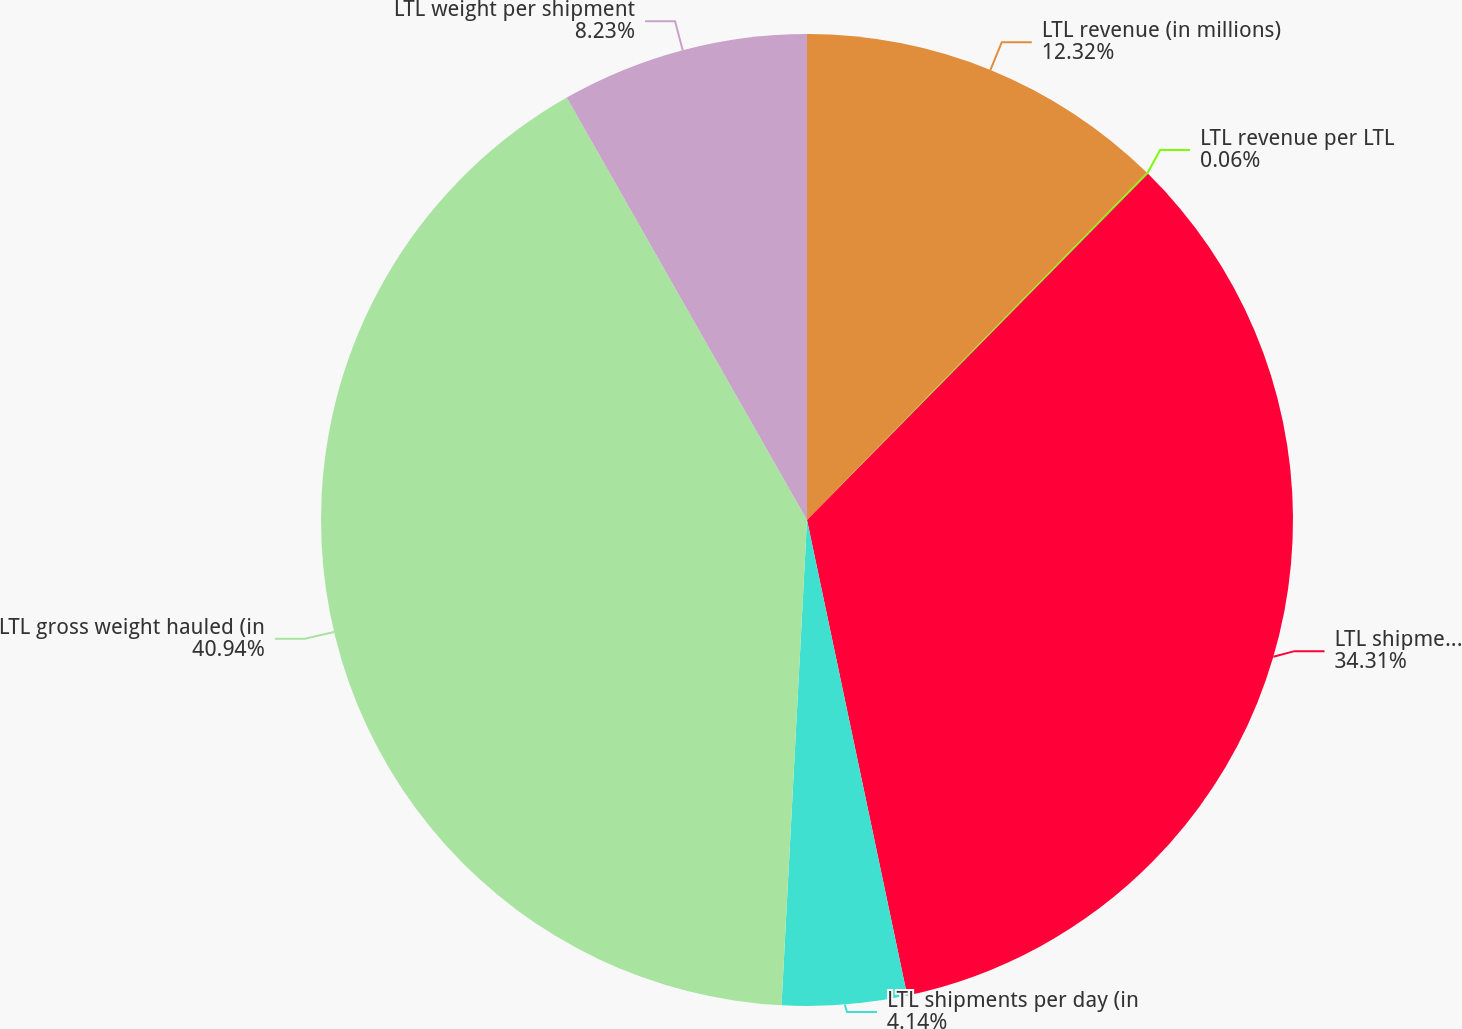Convert chart to OTSL. <chart><loc_0><loc_0><loc_500><loc_500><pie_chart><fcel>LTL revenue (in millions)<fcel>LTL revenue per LTL<fcel>LTL shipments (in thousands)<fcel>LTL shipments per day (in<fcel>LTL gross weight hauled (in<fcel>LTL weight per shipment<nl><fcel>12.32%<fcel>0.06%<fcel>34.31%<fcel>4.14%<fcel>40.93%<fcel>8.23%<nl></chart> 